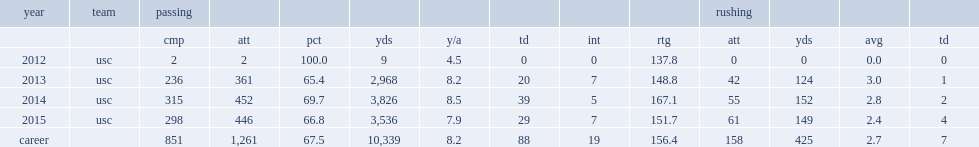How many passing yards did cody kessler get in 2014? 3826.0. 